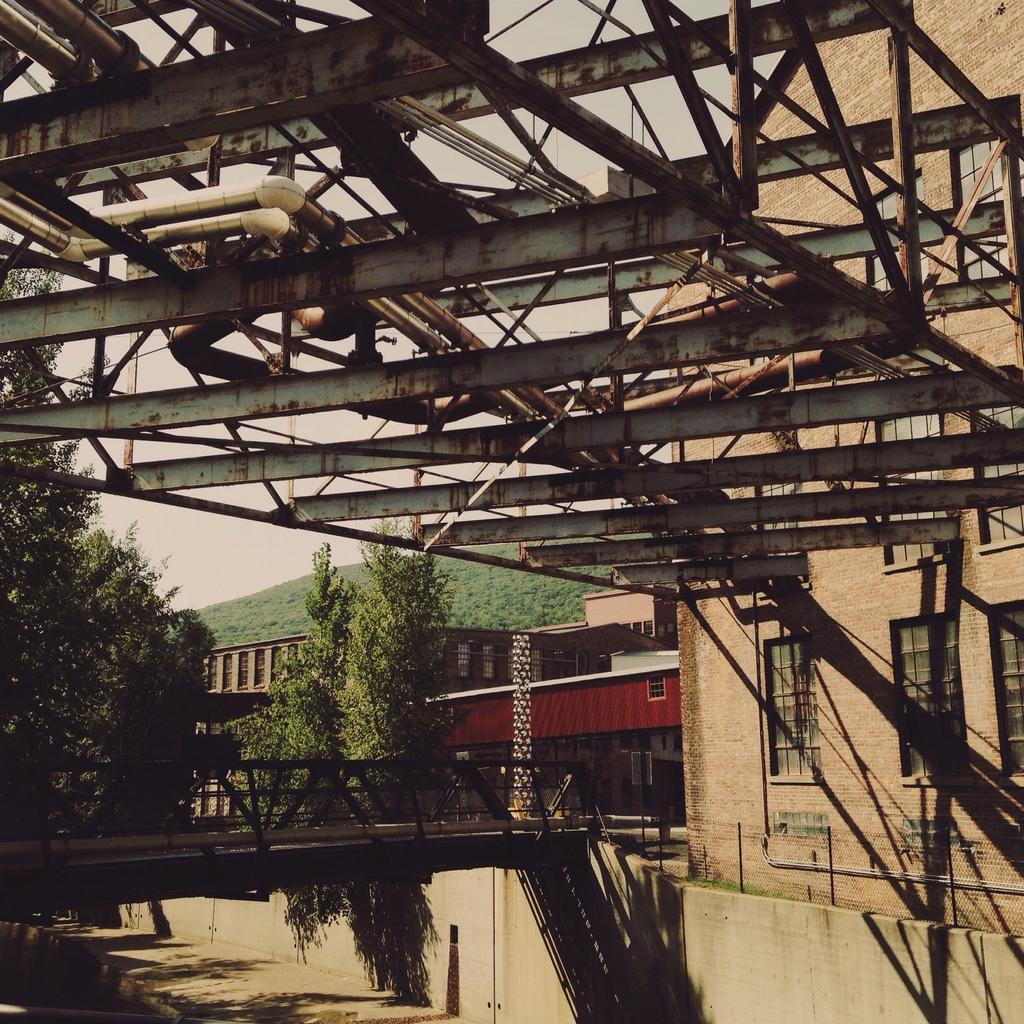What type of structure can be seen in the image? There is a bridge in the image. What other natural elements are present in the image? There are trees in the image. Are there any man-made structures visible? Yes, there are buildings in the image. What type of terrain is depicted in the image? There is a hill in the image. What is the iron frame at the top of the image used for? The purpose of the iron frame at the top of the image is not specified, but it could be part of a structure or a decorative element. What type of pain is being expressed by the trees in the image? There is no indication of pain in the image; the trees are simply depicted as part of the natural landscape. What religious symbols can be seen in the image? There are no religious symbols present in the image. 